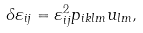Convert formula to latex. <formula><loc_0><loc_0><loc_500><loc_500>\delta \varepsilon _ { i j } = \varepsilon _ { i j } ^ { 2 } p _ { i k l m } u _ { l m } ,</formula> 